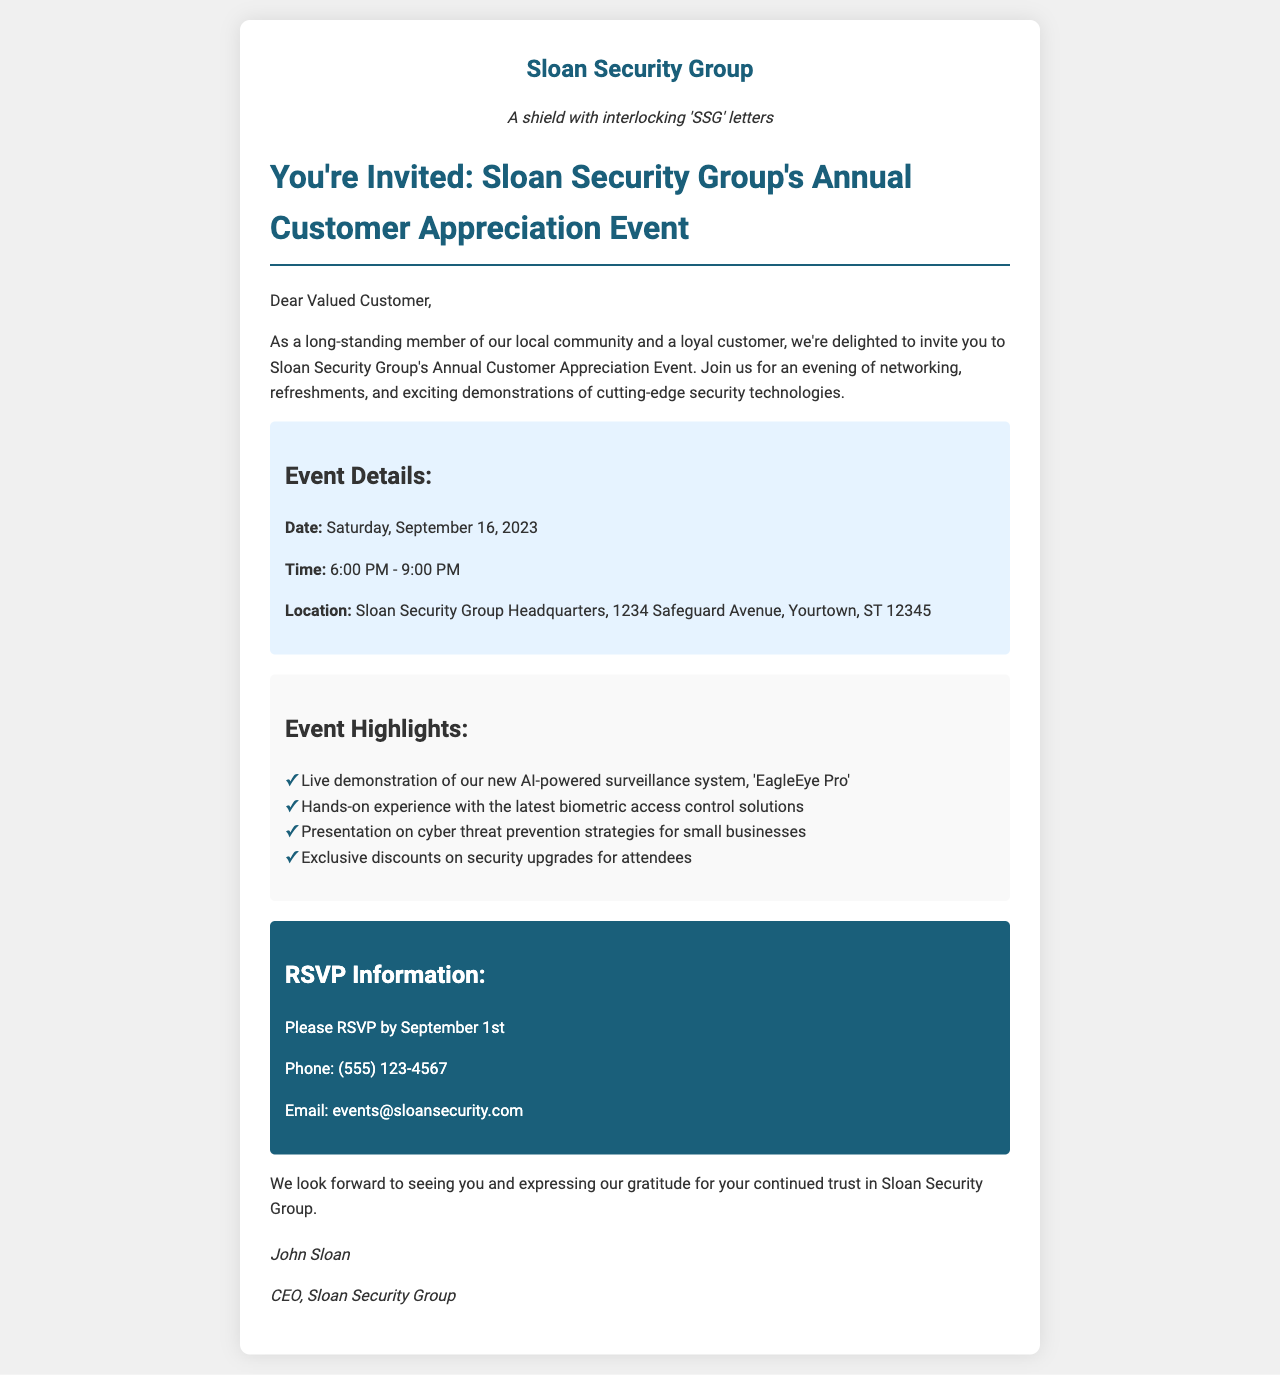what is the date of the event? The event date is specified in the document as September 16, 2023.
Answer: September 16, 2023 what time does the event start? The document states the event time is from 6:00 PM to 9:00 PM.
Answer: 6:00 PM where is the event located? The location is given in the document as Sloan Security Group Headquarters, 1234 Safeguard Avenue, Yourtown, ST 12345.
Answer: 1234 Safeguard Avenue, Yourtown, ST 12345 who is the CEO of Sloan Security Group? The document names John Sloan as the CEO of the company.
Answer: John Sloan what is one of the event highlights? The event highlights mention the "EagleEye Pro" AI-powered surveillance system demonstration as one example.
Answer: AI-powered surveillance system, 'EagleEye Pro' how can attendees RSVP? The document provides contact options for RSVPing, including a phone number and email.
Answer: Phone: (555) 123-4567; Email: events@sloansecurity.com what is the RSVP deadline? The document indicates that the RSVP must be completed by September 1st.
Answer: September 1st what type of refreshments will be available? The document mentions refreshments but does not specify types; it implies networking with refreshments will be part of the event.
Answer: Refreshments 